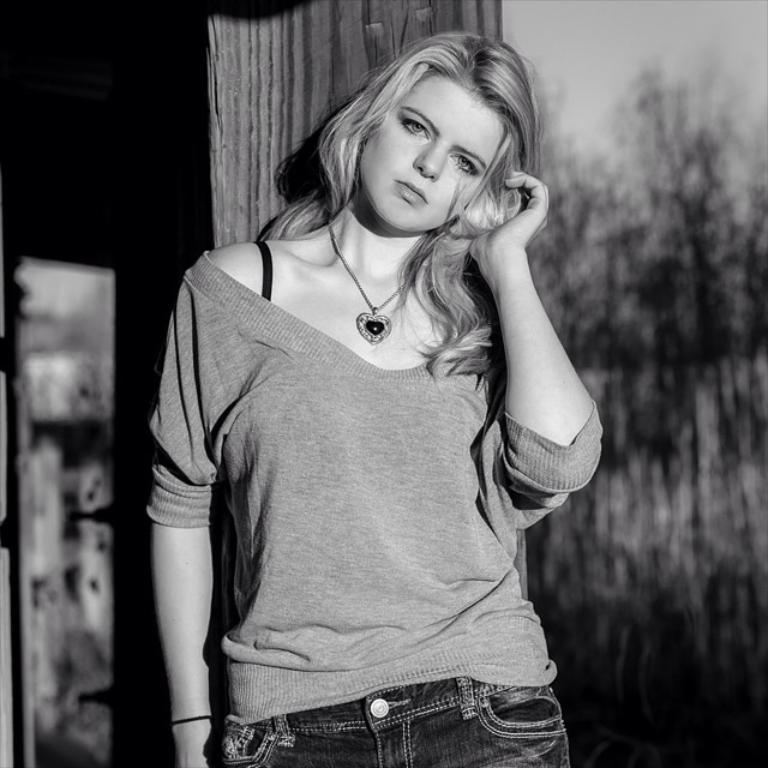Can you describe this image briefly? In the center of the image we can see woman standing. In the background we can see house, trees and sky. 